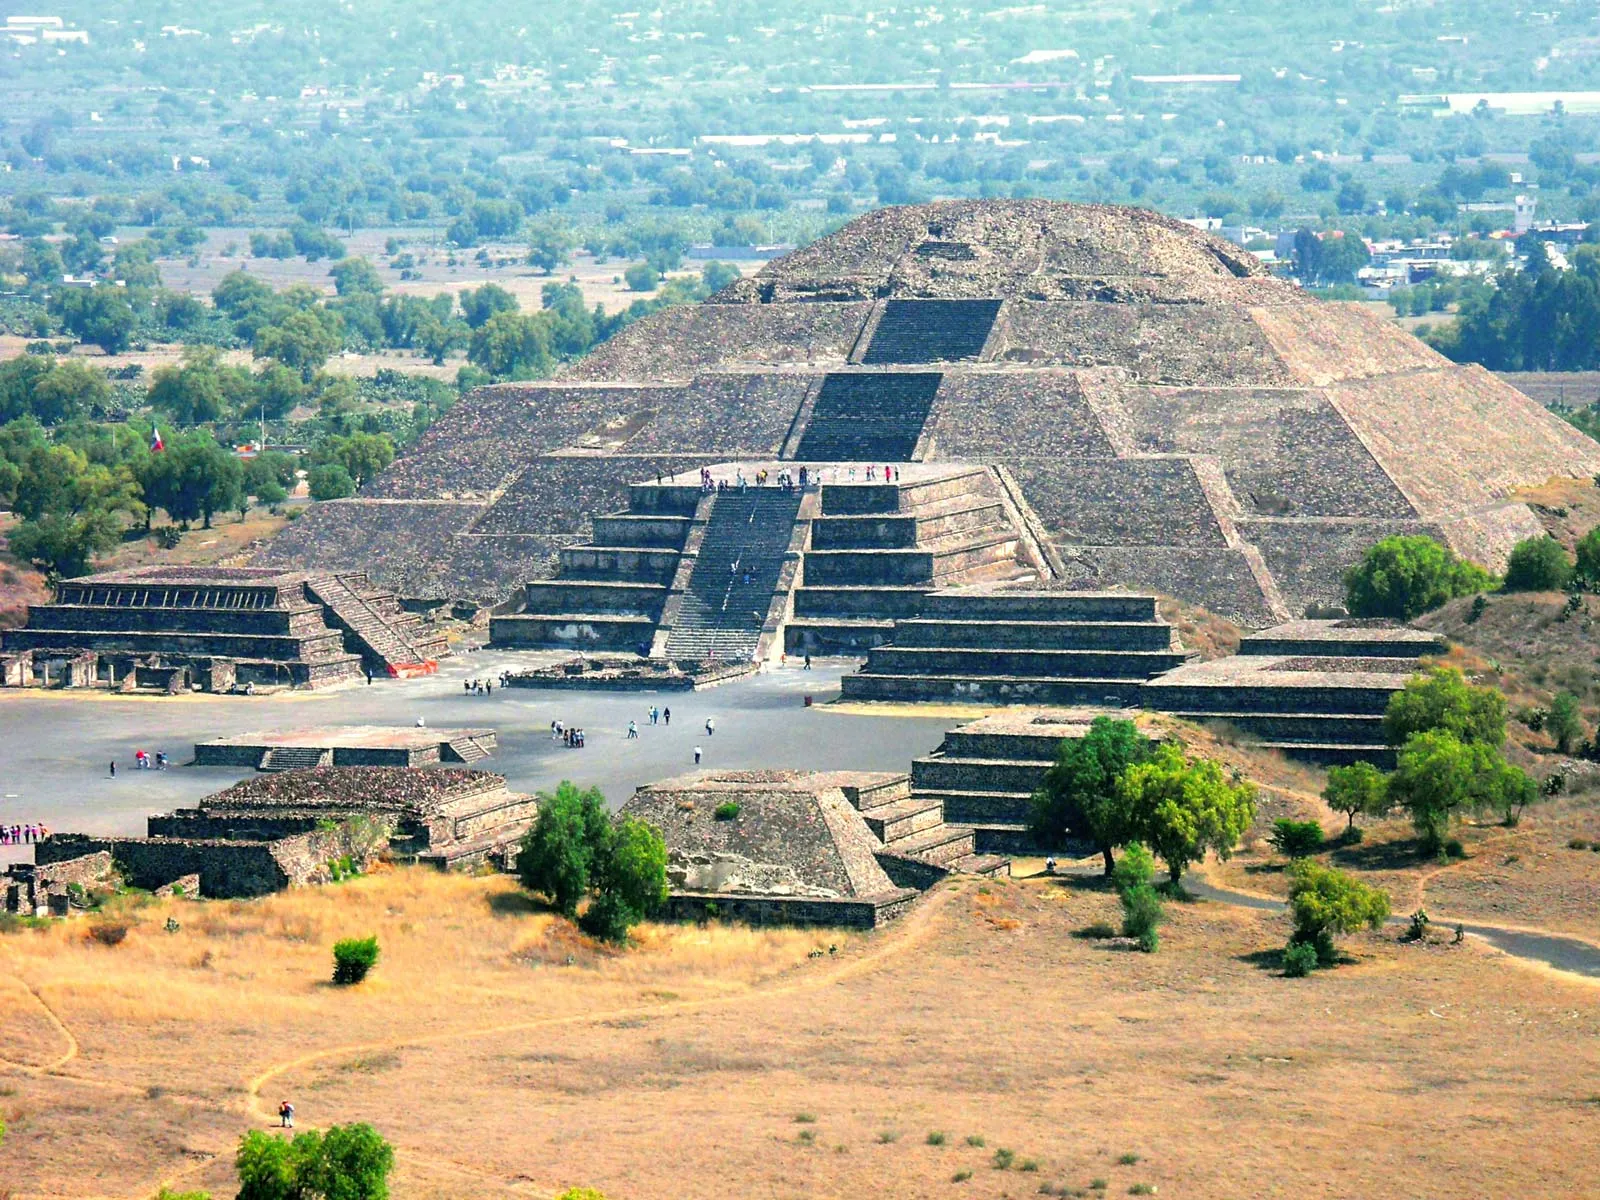Let's imagine a mysterious artifact was found at the top of this pyramid. What could it be, and what secrets might it reveal? Let’s imagine discovering an ancient, intricately carved stone tablet at the summit of the Pyramid of the Sun. This artifact might be covered in hieroglyphics and symbolic figures that tell a detailed story of the Teotihuacan civilization. As scholars study the tablet, they might uncover insights into the daily life, religious beliefs, and the astronomical knowledge of the Teotihuacan people. The carvings could reveal the names of forgotten leaders, detailed records of significant events, trade routes, and alliances with neighboring regions. Additionally, there might be hints about the purpose and meaning of other structures within the city, shedding light on the intertwined relationship between their architectural achievements and their understanding of the cosmos. This artifact could hold the key to reviving lost knowledge and providing a deeper understanding of this enigmatic civilization. 